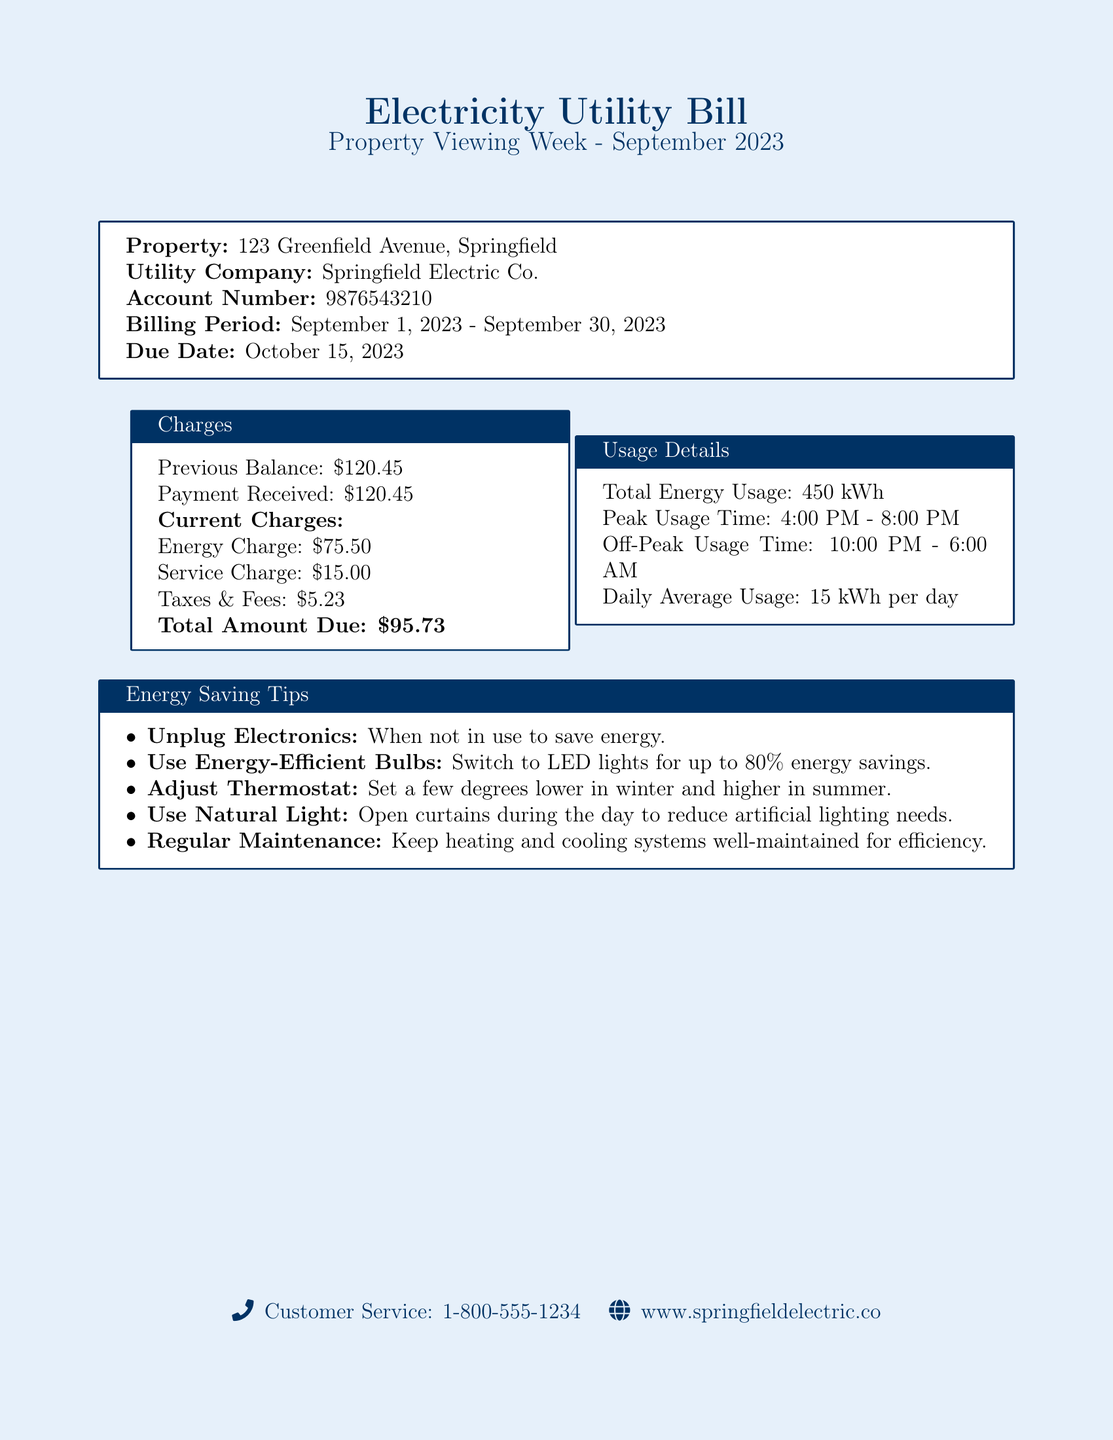What is the property address? The property address is specified in the document as the location of the electricity utility bill.
Answer: 123 Greenfield Avenue, Springfield What is the total amount due? The total amount due is clearly stated in the charges section of the document.
Answer: \$95.73 What is the billing period for this statement? The billing period is outlined at the top of the document.
Answer: September 1, 2023 - September 30, 2023 What is the total energy usage for September 2023? The total energy usage is detailed in the usage section of the document.
Answer: 450 kWh What is the peak usage time? The peak usage time is specified under the usage details.
Answer: 4:00 PM - 8:00 PM What percentage of energy savings can LED lights provide? The energy-saving tips mention the percentage potential for savings with LED lights.
Answer: up to 80% When is the due date for the payment? The due date is mentioned in the summary of the utility bill’s billing information.
Answer: October 15, 2023 How much was the previous balance? The previous balance is listed in the charges section of the bill.
Answer: \$120.45 What is listed as a tip for saving energy? The document provides specific energy-saving tips; one of them is highlighted.
Answer: Unplug Electronics 